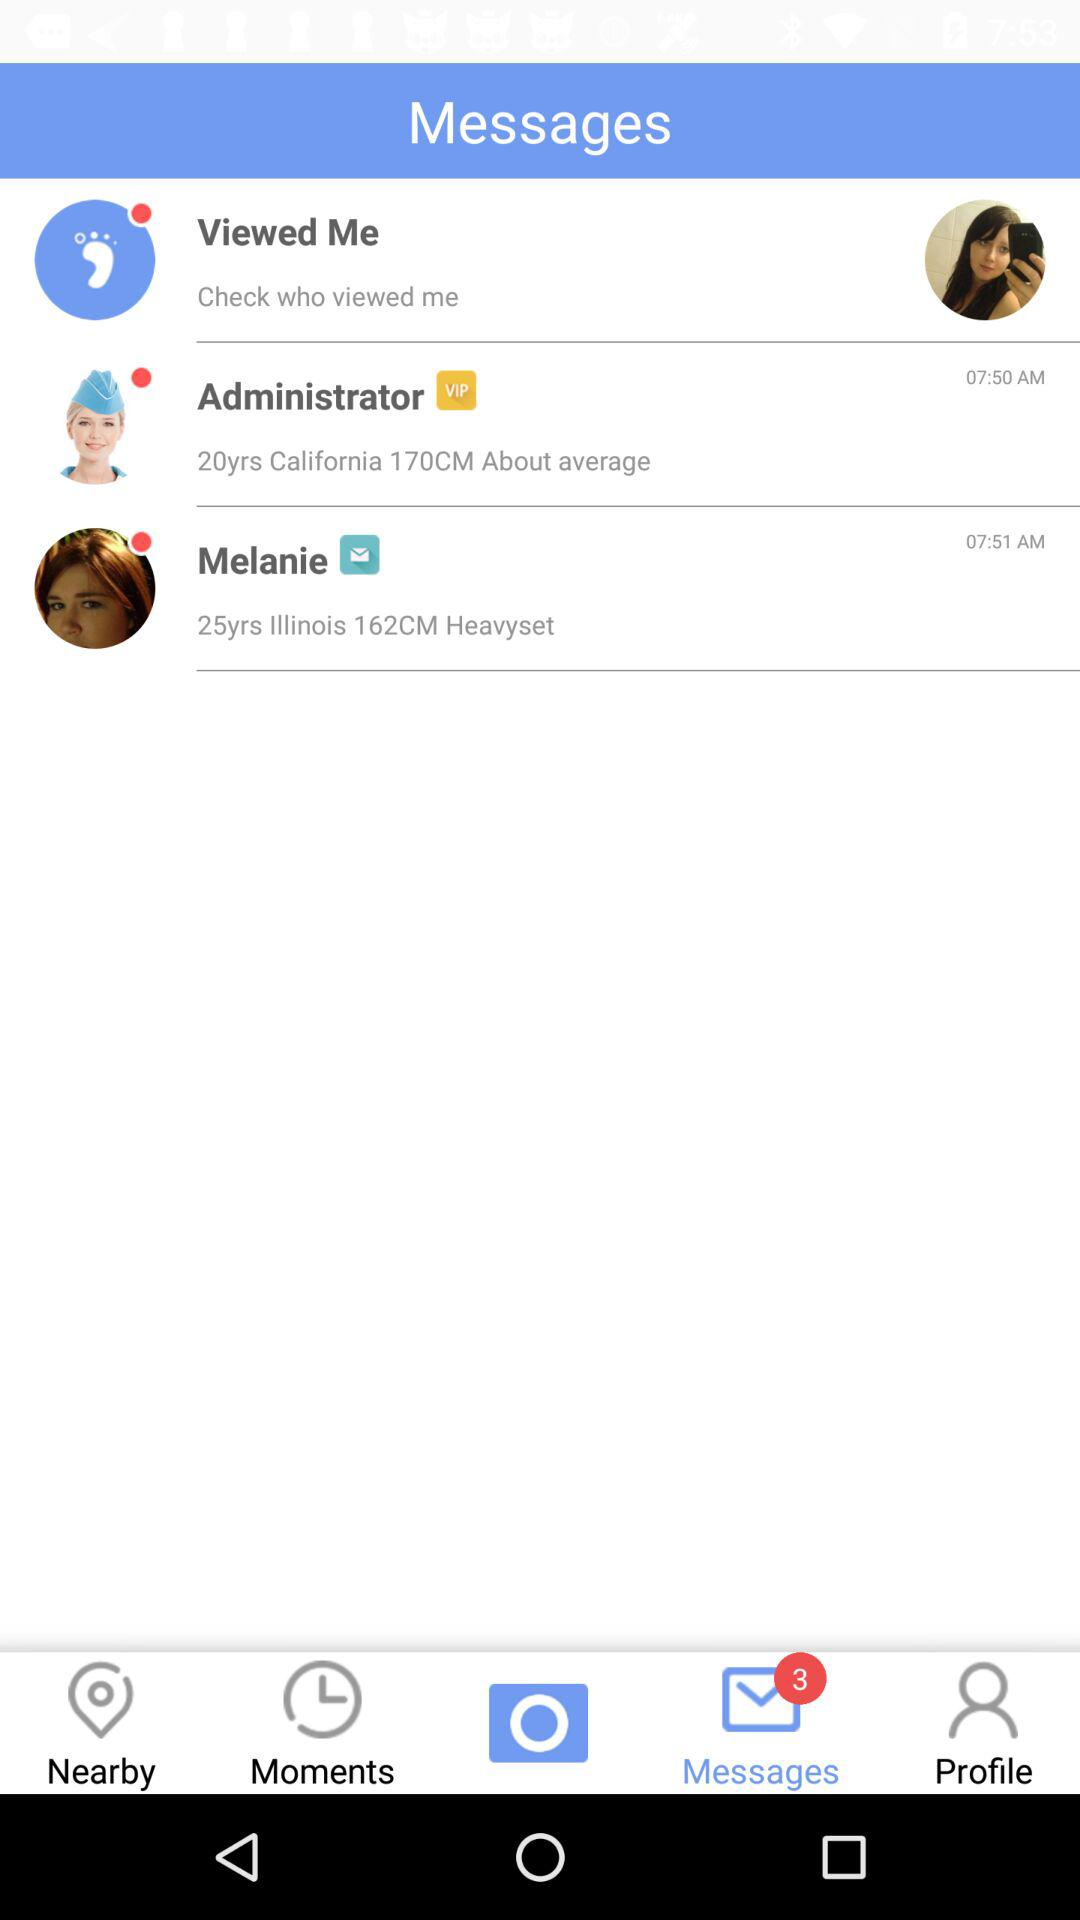What is the time when the message comes from Melanie? The time is 07:51 am. 